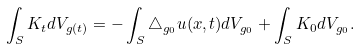Convert formula to latex. <formula><loc_0><loc_0><loc_500><loc_500>\int _ { S } K _ { t } d V _ { g ( t ) } = - \int _ { S } \triangle _ { g _ { 0 } } u ( x , t ) d V _ { g _ { 0 } } + \int _ { S } K _ { 0 } d V _ { g _ { 0 } } .</formula> 